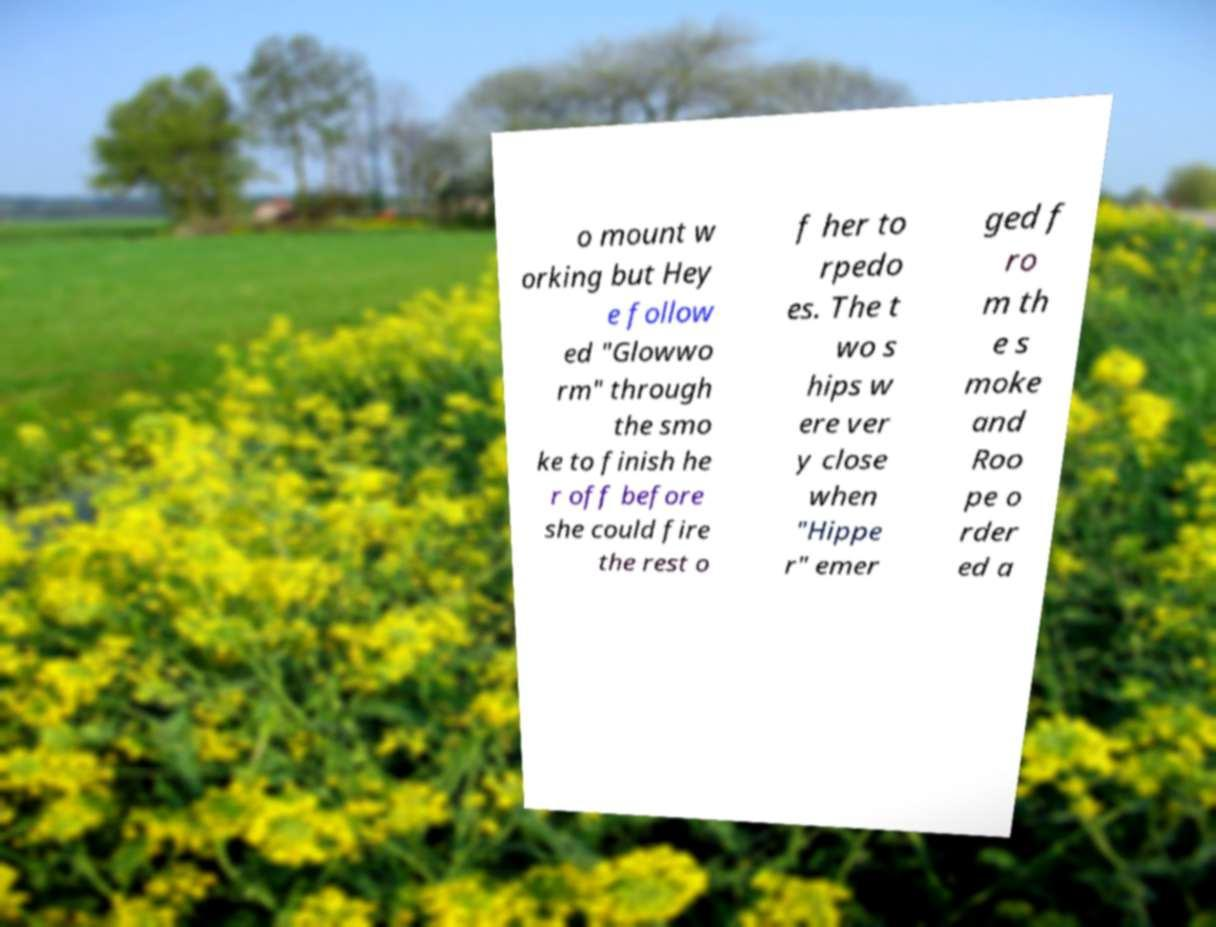Can you accurately transcribe the text from the provided image for me? o mount w orking but Hey e follow ed "Glowwo rm" through the smo ke to finish he r off before she could fire the rest o f her to rpedo es. The t wo s hips w ere ver y close when "Hippe r" emer ged f ro m th e s moke and Roo pe o rder ed a 